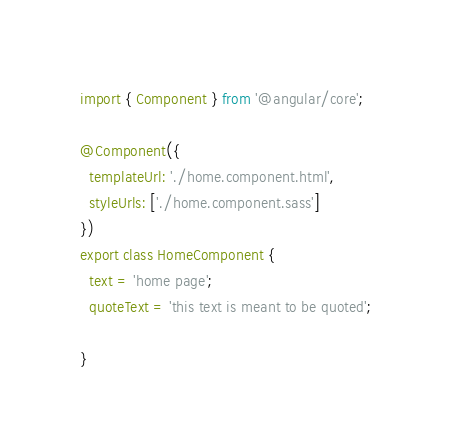<code> <loc_0><loc_0><loc_500><loc_500><_TypeScript_>import { Component } from '@angular/core';

@Component({
  templateUrl: './home.component.html',
  styleUrls: ['./home.component.sass']
})
export class HomeComponent {
  text = 'home page';
  quoteText = 'this text is meant to be quoted';

}
</code> 